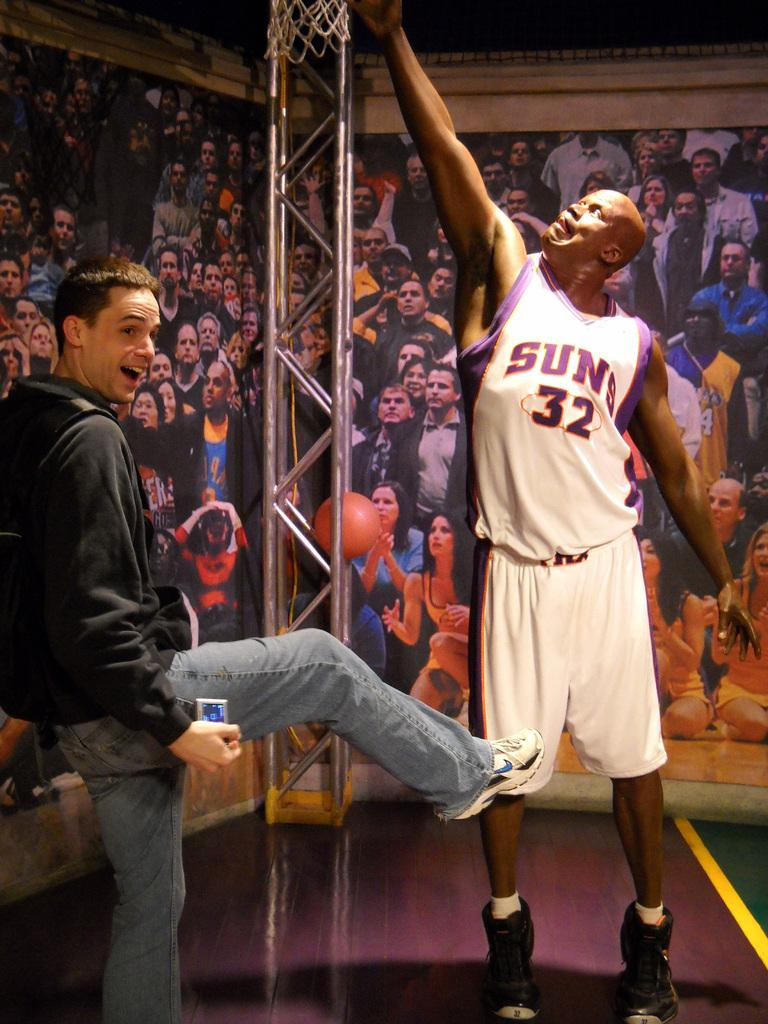Provide a one-sentence caption for the provided image. A man poses with a statue of Suns player number 32. 